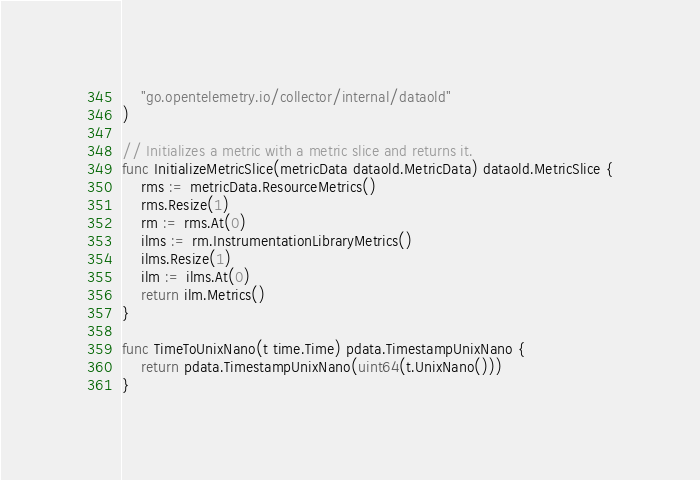<code> <loc_0><loc_0><loc_500><loc_500><_Go_>	"go.opentelemetry.io/collector/internal/dataold"
)

// Initializes a metric with a metric slice and returns it.
func InitializeMetricSlice(metricData dataold.MetricData) dataold.MetricSlice {
	rms := metricData.ResourceMetrics()
	rms.Resize(1)
	rm := rms.At(0)
	ilms := rm.InstrumentationLibraryMetrics()
	ilms.Resize(1)
	ilm := ilms.At(0)
	return ilm.Metrics()
}

func TimeToUnixNano(t time.Time) pdata.TimestampUnixNano {
	return pdata.TimestampUnixNano(uint64(t.UnixNano()))
}
</code> 